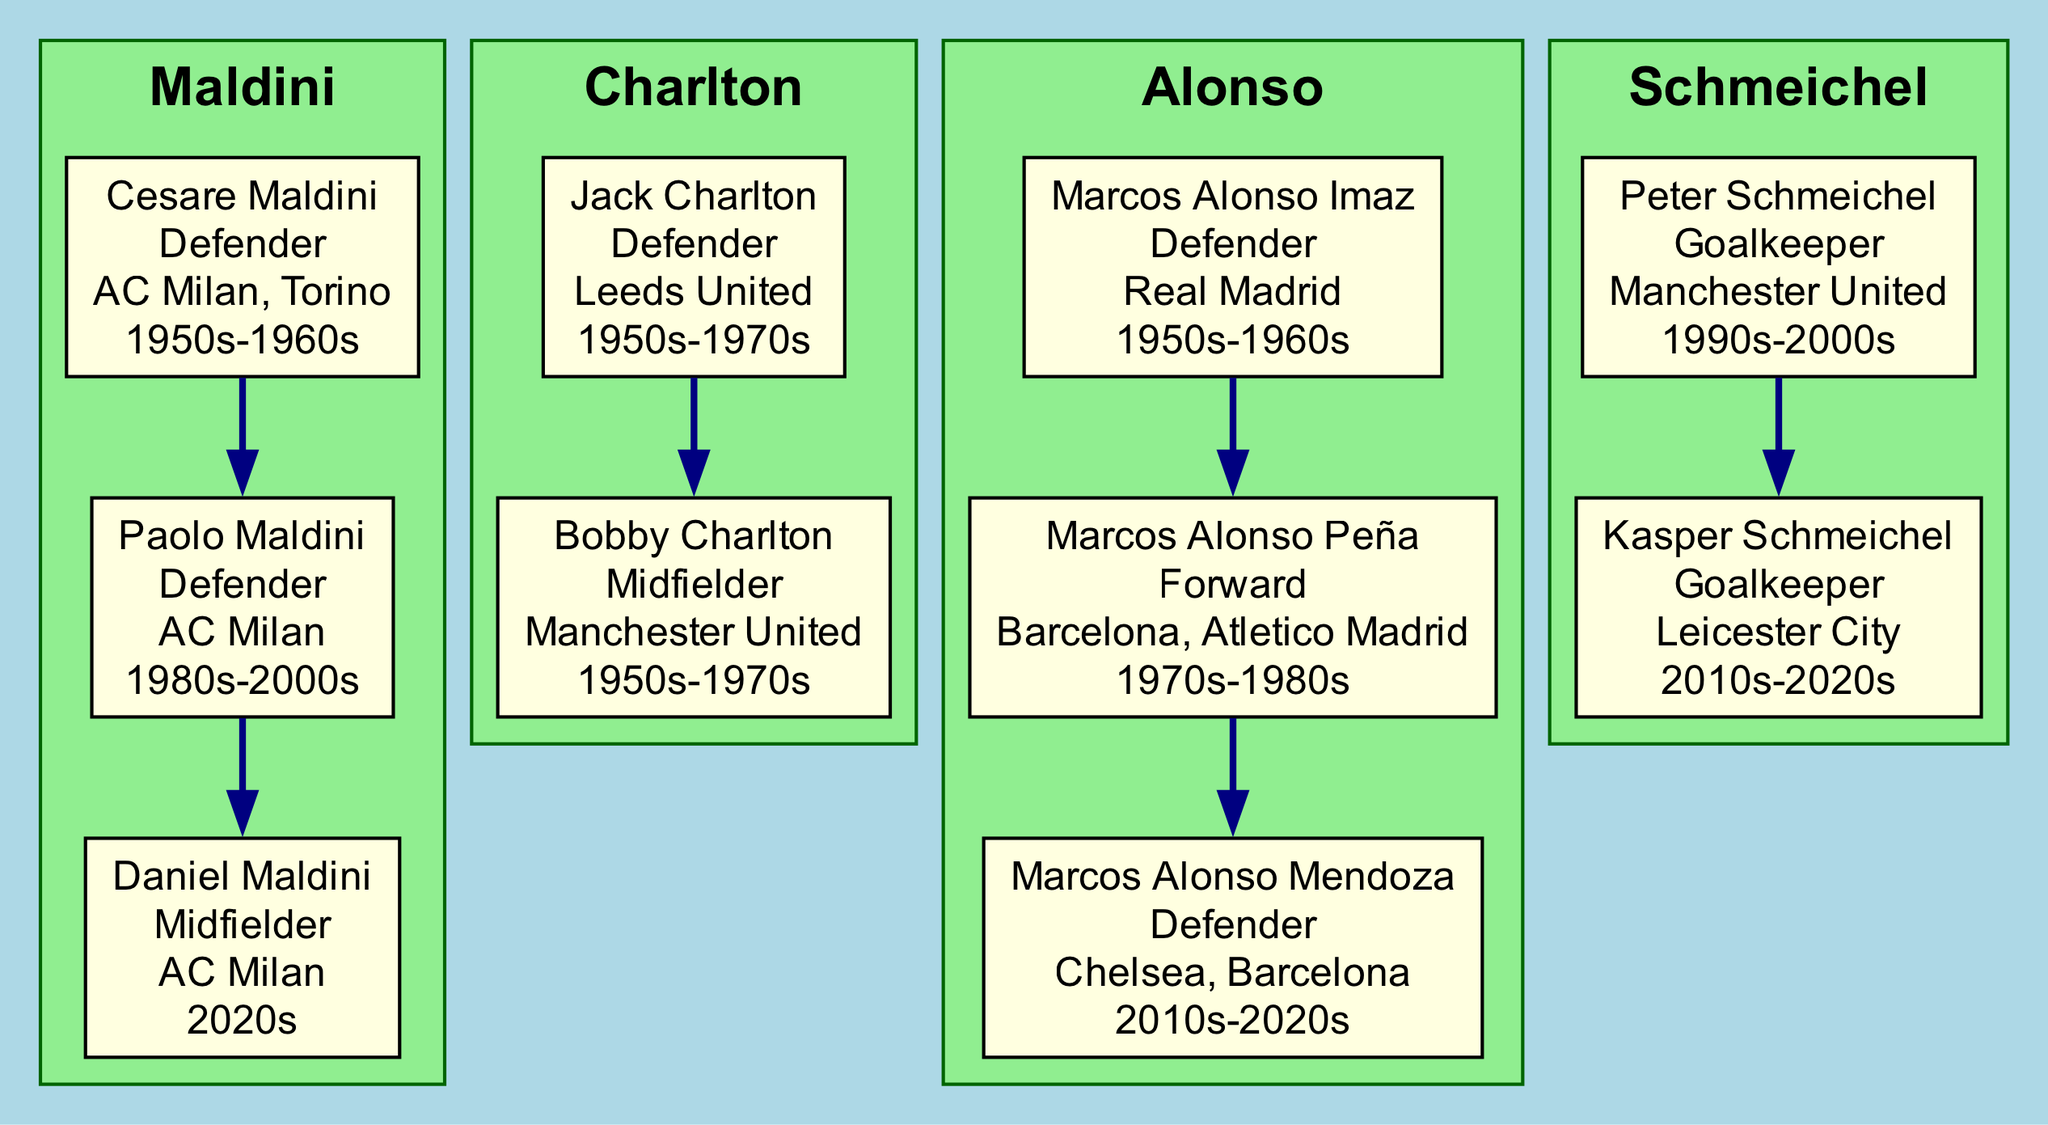What is the first name of the defender from the Maldini family? The diagram shows that the first generation of the Maldini family includes Cesare Maldini, and his role is listed as Defender.
Answer: Cesare How many generations are there in the Schmeichel family? The Schmeichel family has two generations displayed: Peter Schmeichel and Kasper Schmeichel.
Answer: 2 Which team did Jack Charlton play for? Referring to the Charlton family section of the diagram, Jack Charlton played for Leeds United.
Answer: Leeds United Name one of the teams played by Marcos Alonso Imaz. The diagram indicates that Marcos Alonso Imaz played for Real Madrid, among other teams mentioned for the Alonso family.
Answer: Real Madrid In which era did Paolo Maldini play? The diagram specifies that Paolo Maldini played in the era between the 1980s and 2000s, which can be found in his generational information.
Answer: 1980s-2000s Which family has a goalkeeper in the latest generation? The Schmeichel family has a goalkeeper in the latest generation, specifically Kasper Schmeichel.
Answer: Schmeichel What role did Bobby Charlton play? The information in the diagram states that Bobby Charlton played as a Midfielder.
Answer: Midfielder Which family has the most generations represented? The Maldini family is the one with three generations: Cesare, Paolo, and Daniel Maldini.
Answer: Maldini Who played for both Barcelona and Atletico Madrid? The diagram indicates that Marcos Alonso Peña played for both Barcelona and Atletico Madrid during his career.
Answer: Marcos Alonso Peña 